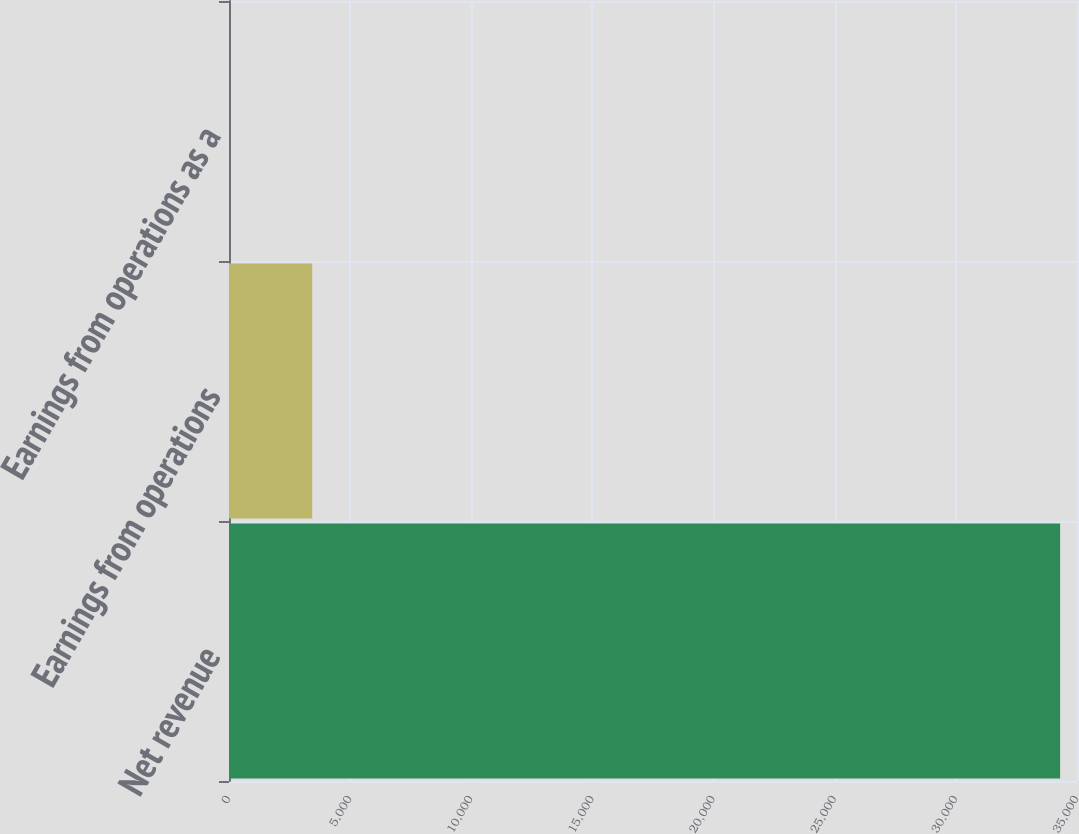<chart> <loc_0><loc_0><loc_500><loc_500><bar_chart><fcel>Net revenue<fcel>Earnings from operations<fcel>Earnings from operations as a<nl><fcel>34303<fcel>3433.63<fcel>3.7<nl></chart> 